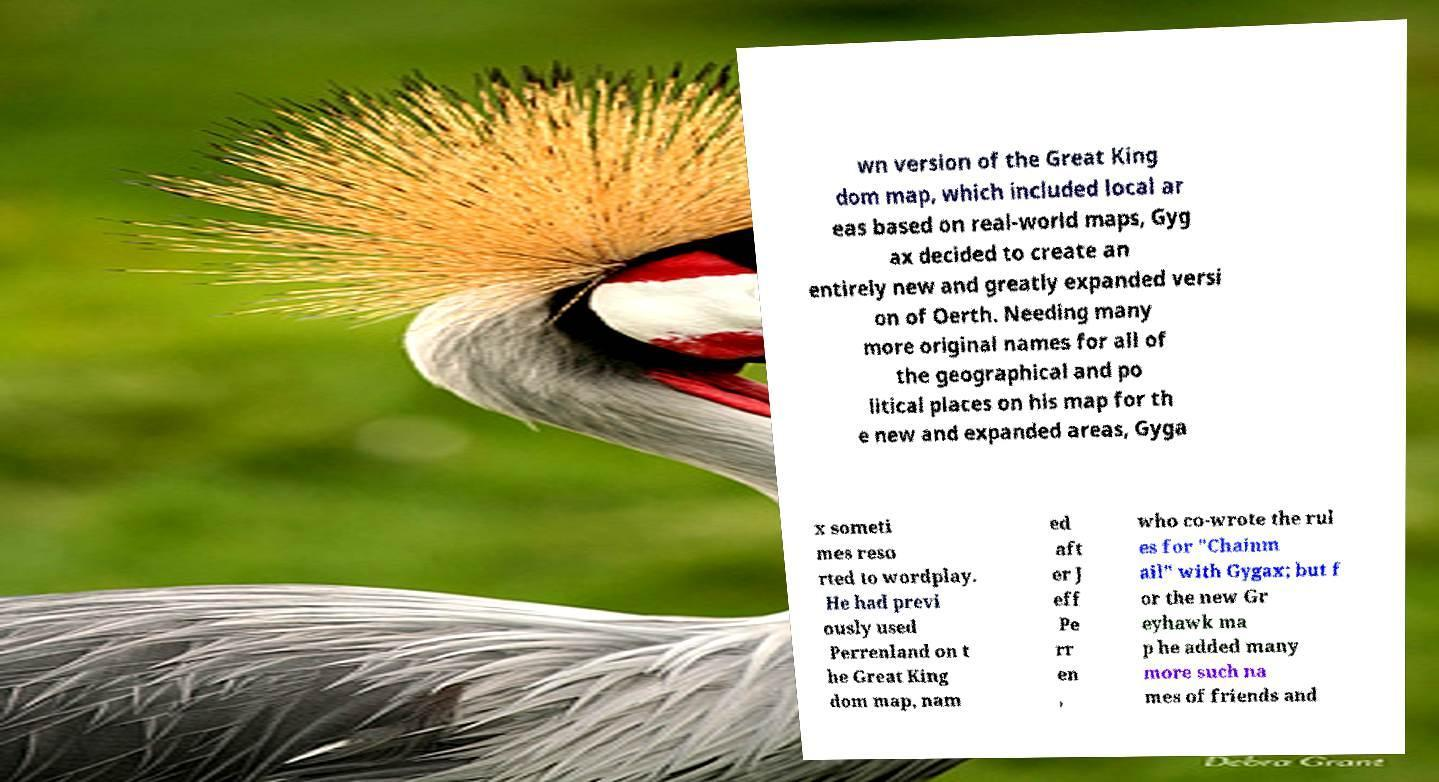Can you accurately transcribe the text from the provided image for me? wn version of the Great King dom map, which included local ar eas based on real-world maps, Gyg ax decided to create an entirely new and greatly expanded versi on of Oerth. Needing many more original names for all of the geographical and po litical places on his map for th e new and expanded areas, Gyga x someti mes reso rted to wordplay. He had previ ously used Perrenland on t he Great King dom map, nam ed aft er J eff Pe rr en , who co-wrote the rul es for "Chainm ail" with Gygax; but f or the new Gr eyhawk ma p he added many more such na mes of friends and 